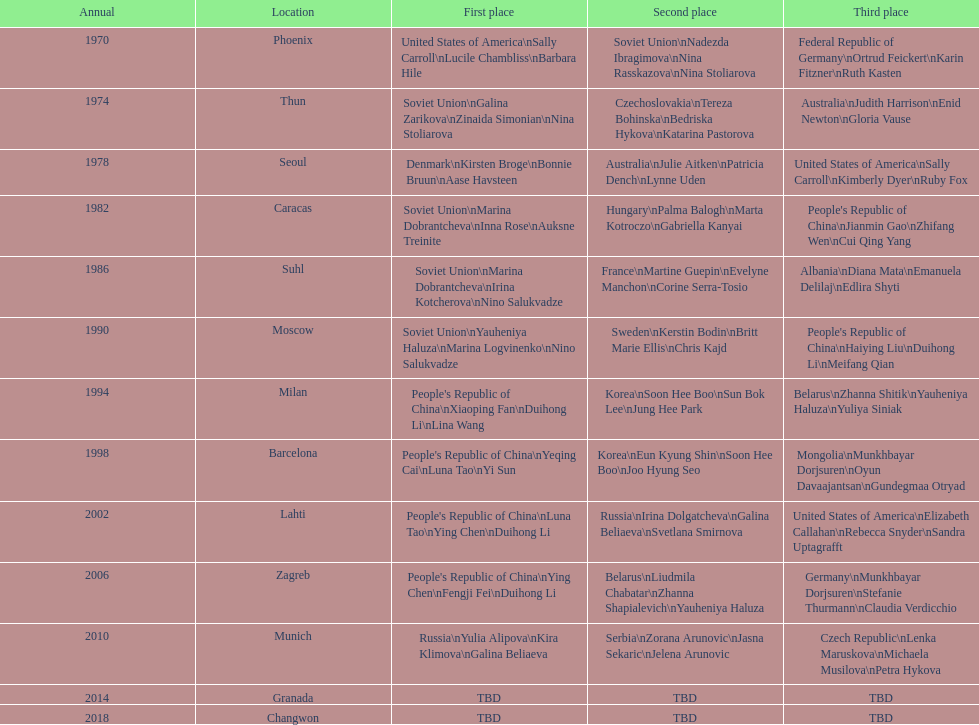Name one of the top three women to earn gold at the 1970 world championship held in phoenix, az Sally Carroll. 